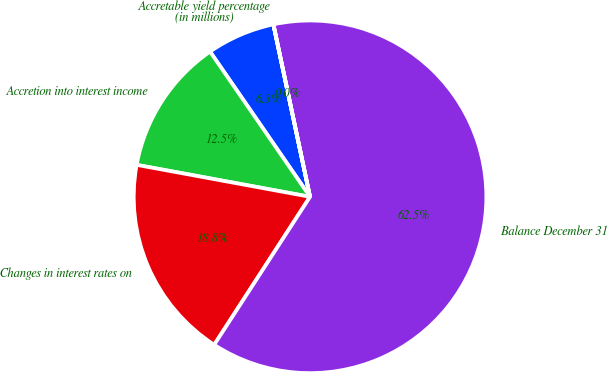Convert chart. <chart><loc_0><loc_0><loc_500><loc_500><pie_chart><fcel>(in millions)<fcel>Accretion into interest income<fcel>Changes in interest rates on<fcel>Balance December 31<fcel>Accretable yield percentage<nl><fcel>6.26%<fcel>12.5%<fcel>18.75%<fcel>62.47%<fcel>0.01%<nl></chart> 